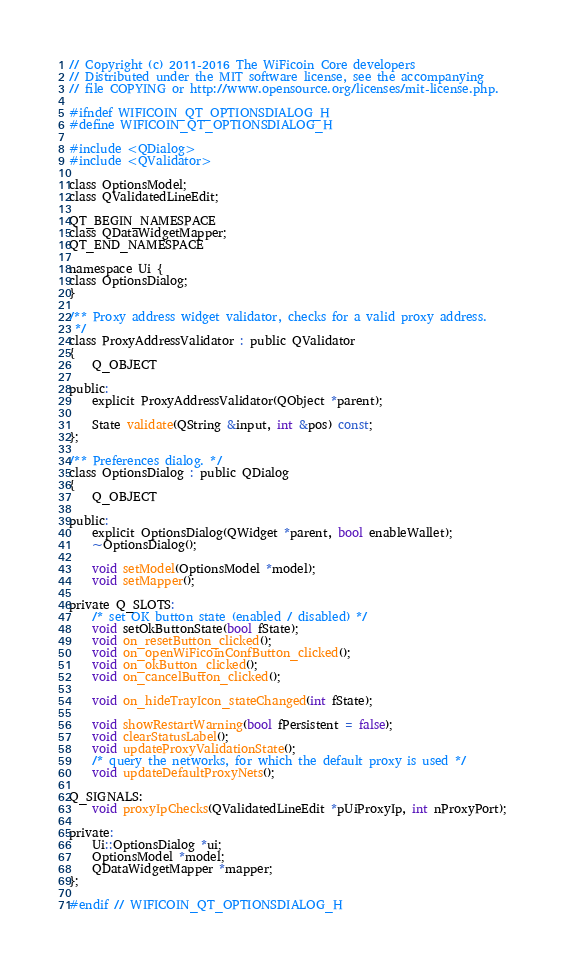<code> <loc_0><loc_0><loc_500><loc_500><_C_>// Copyright (c) 2011-2016 The WiFicoin Core developers
// Distributed under the MIT software license, see the accompanying
// file COPYING or http://www.opensource.org/licenses/mit-license.php.

#ifndef WIFICOIN_QT_OPTIONSDIALOG_H
#define WIFICOIN_QT_OPTIONSDIALOG_H

#include <QDialog>
#include <QValidator>

class OptionsModel;
class QValidatedLineEdit;

QT_BEGIN_NAMESPACE
class QDataWidgetMapper;
QT_END_NAMESPACE

namespace Ui {
class OptionsDialog;
}

/** Proxy address widget validator, checks for a valid proxy address.
 */
class ProxyAddressValidator : public QValidator
{
    Q_OBJECT

public:
    explicit ProxyAddressValidator(QObject *parent);

    State validate(QString &input, int &pos) const;
};

/** Preferences dialog. */
class OptionsDialog : public QDialog
{
    Q_OBJECT

public:
    explicit OptionsDialog(QWidget *parent, bool enableWallet);
    ~OptionsDialog();

    void setModel(OptionsModel *model);
    void setMapper();

private Q_SLOTS:
    /* set OK button state (enabled / disabled) */
    void setOkButtonState(bool fState);
    void on_resetButton_clicked();
    void on_openWiFicoinConfButton_clicked();
    void on_okButton_clicked();
    void on_cancelButton_clicked();
    
    void on_hideTrayIcon_stateChanged(int fState);

    void showRestartWarning(bool fPersistent = false);
    void clearStatusLabel();
    void updateProxyValidationState();
    /* query the networks, for which the default proxy is used */
    void updateDefaultProxyNets();

Q_SIGNALS:
    void proxyIpChecks(QValidatedLineEdit *pUiProxyIp, int nProxyPort);

private:
    Ui::OptionsDialog *ui;
    OptionsModel *model;
    QDataWidgetMapper *mapper;
};

#endif // WIFICOIN_QT_OPTIONSDIALOG_H
</code> 